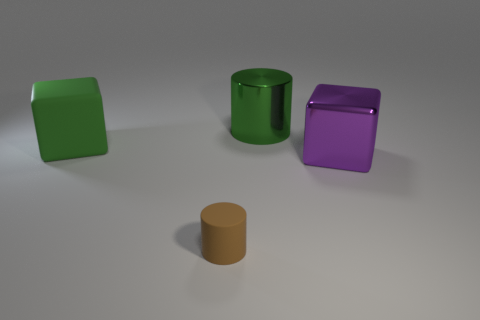What colors are the objects in the image? The objects exhibit a variety of colors: one is green, another is purple, there's also a tan object, and I see a green cylinder. Are all objects the same shape? No, the objects have two distinct shapes. Some are cubic and others are cylindrical. 